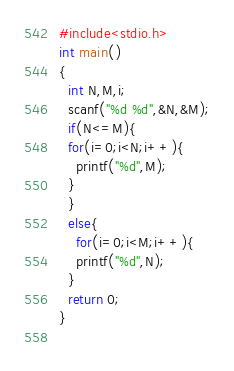<code> <loc_0><loc_0><loc_500><loc_500><_C_>#include<stdio.h>
int main()
{
  int N,M,i;
  scanf("%d %d",&N,&M);
  if(N<=M){
  for(i=0;i<N;i++){
    printf("%d",M);
  }
  }
  else{
    for(i=0;i<M;i++){
    printf("%d",N);
  }
  return 0;
}
  
</code> 